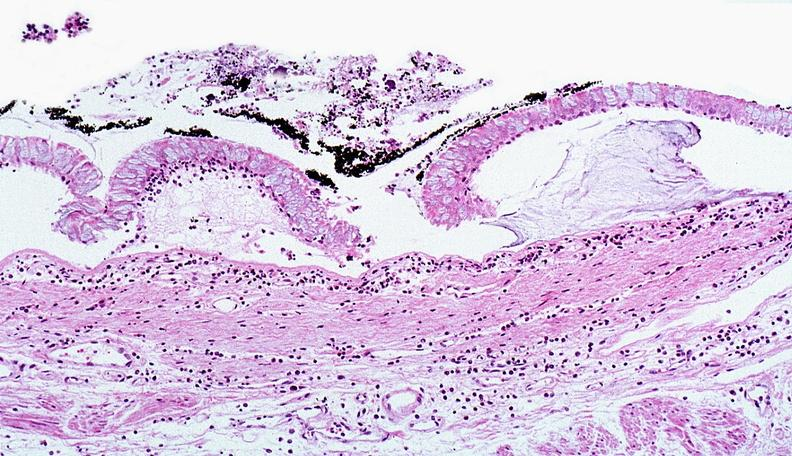does this image show thermal burned skin?
Answer the question using a single word or phrase. Yes 